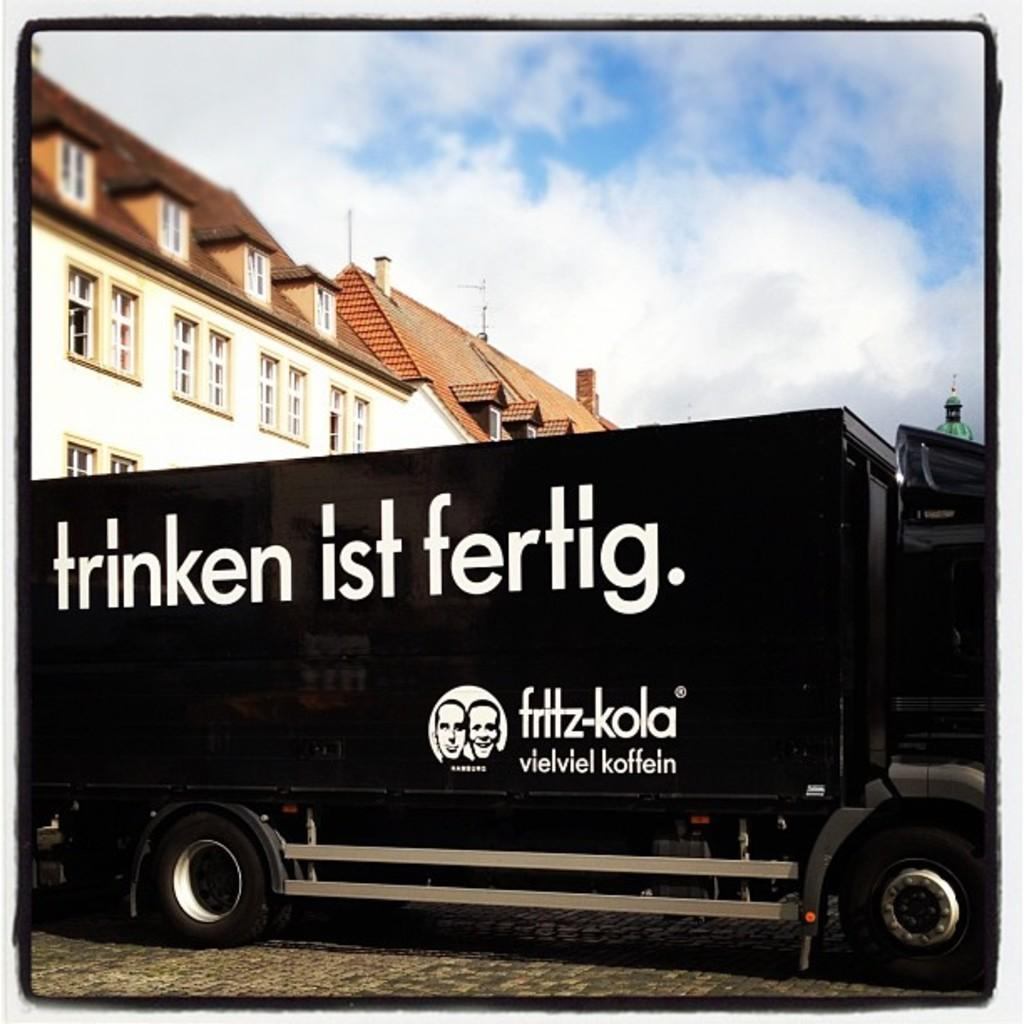What type of vehicle is in the image? There is a black truck in the image. Where is the truck located in the image? The truck is on a path in the image. What can be seen in the background of the image? There are buildings, walls, windows, and a cloudy sky visible in the background of the image. What type of camera is used to take the picture of the truck? The facts provided do not mention any camera or photography equipment, so we cannot determine the type of camera used to take the picture. 